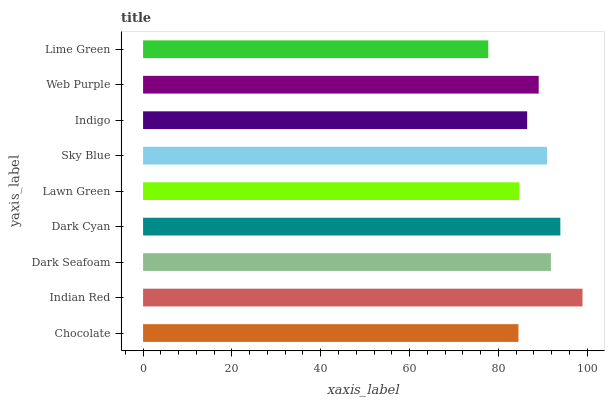Is Lime Green the minimum?
Answer yes or no. Yes. Is Indian Red the maximum?
Answer yes or no. Yes. Is Dark Seafoam the minimum?
Answer yes or no. No. Is Dark Seafoam the maximum?
Answer yes or no. No. Is Indian Red greater than Dark Seafoam?
Answer yes or no. Yes. Is Dark Seafoam less than Indian Red?
Answer yes or no. Yes. Is Dark Seafoam greater than Indian Red?
Answer yes or no. No. Is Indian Red less than Dark Seafoam?
Answer yes or no. No. Is Web Purple the high median?
Answer yes or no. Yes. Is Web Purple the low median?
Answer yes or no. Yes. Is Dark Cyan the high median?
Answer yes or no. No. Is Dark Cyan the low median?
Answer yes or no. No. 